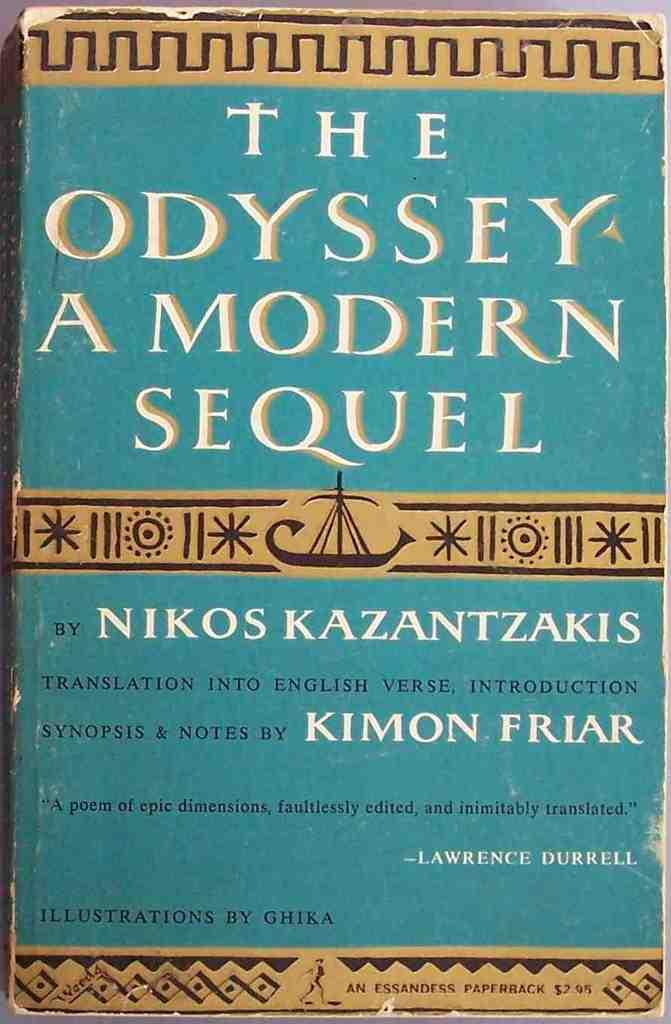<image>
Summarize the visual content of the image. Vintage book title that reads The Odyssey a modern sequel. 